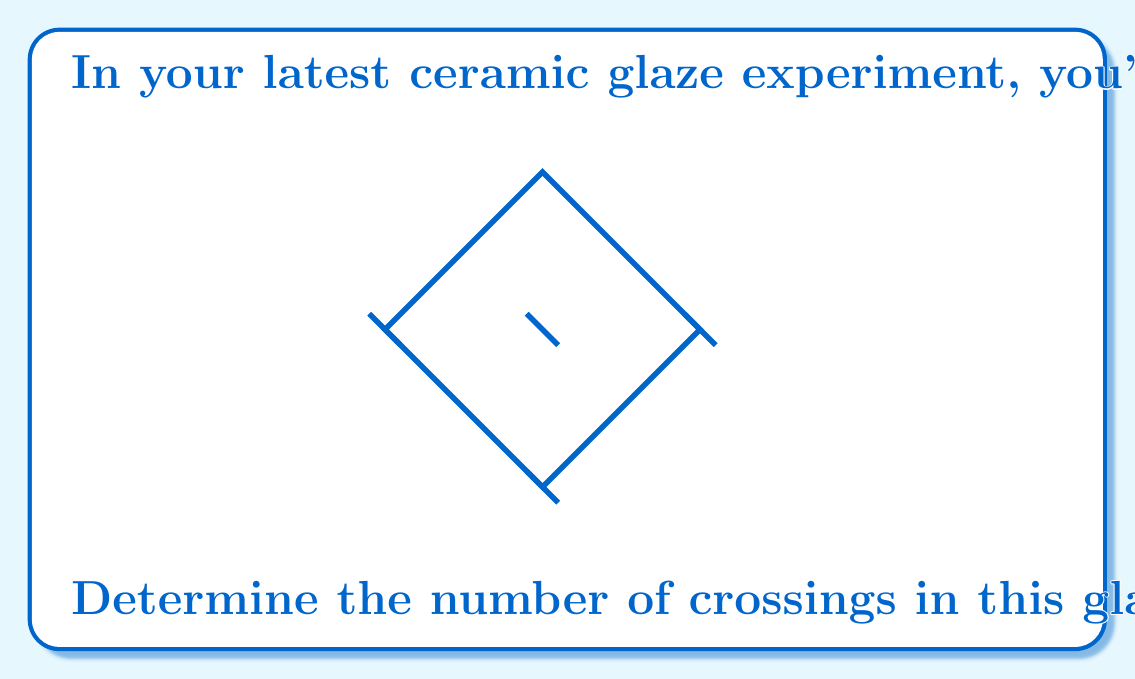Give your solution to this math problem. To determine the number of crossings in the given knot diagram, we need to count the points where the knot crosses over or under itself. Let's analyze the diagram step by step:

1. The knot forms a closed loop with four main sections.

2. Starting from any point and following the knot, we can see that it crosses itself at four distinct locations:
   a) Near the top of the diagram
   b) On the right side
   c) Near the bottom of the diagram
   d) On the left side

3. Each of these crossings is represented by a small gap in one of the lines, indicating where one strand passes over another.

4. It's important to note that in knot theory, we count each crossing only once, regardless of which strand is on top.

5. Therefore, we simply need to count the number of locations where the knot intersects itself.

In this case, there are exactly 4 such intersections or crossings.
Answer: 4 